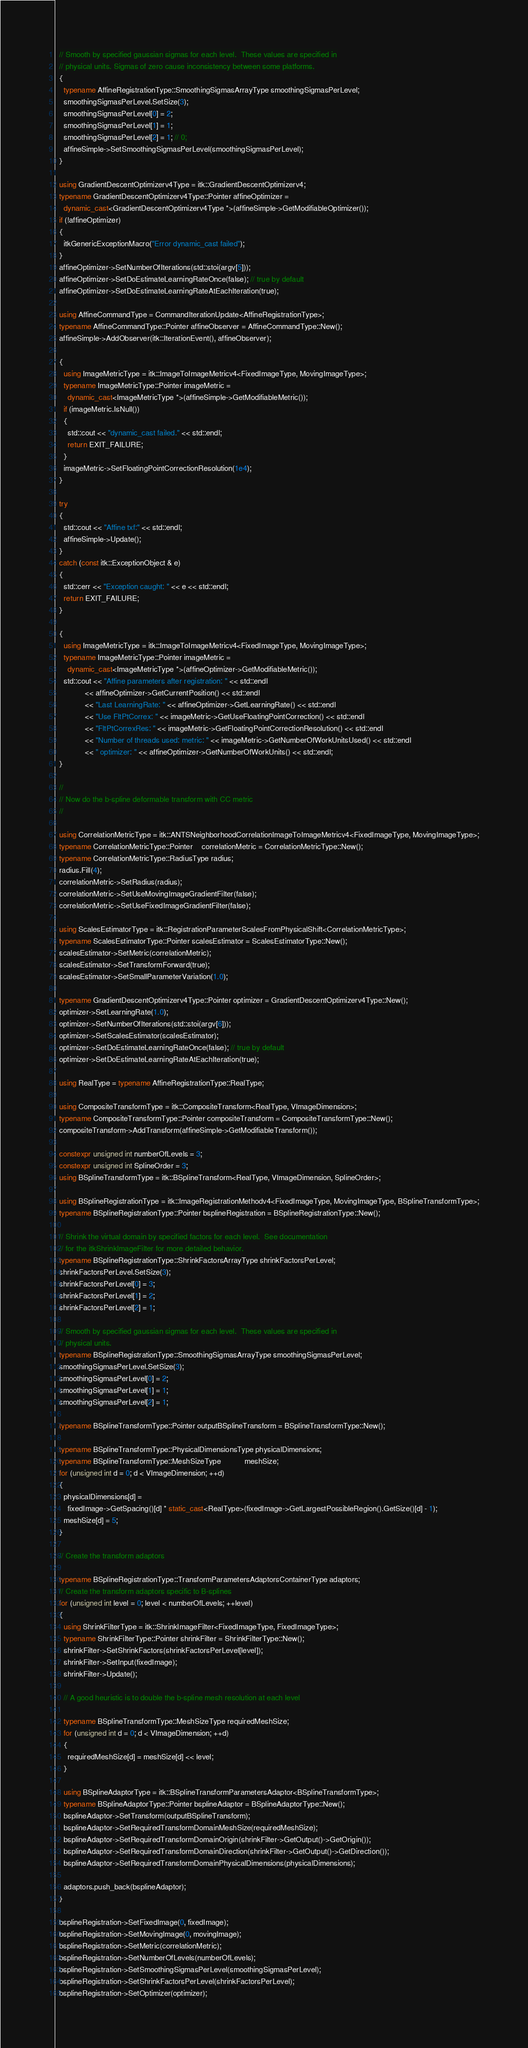<code> <loc_0><loc_0><loc_500><loc_500><_C++_>  // Smooth by specified gaussian sigmas for each level.  These values are specified in
  // physical units. Sigmas of zero cause inconsistency between some platforms.
  {
    typename AffineRegistrationType::SmoothingSigmasArrayType smoothingSigmasPerLevel;
    smoothingSigmasPerLevel.SetSize(3);
    smoothingSigmasPerLevel[0] = 2;
    smoothingSigmasPerLevel[1] = 1;
    smoothingSigmasPerLevel[2] = 1; // 0;
    affineSimple->SetSmoothingSigmasPerLevel(smoothingSigmasPerLevel);
  }

  using GradientDescentOptimizerv4Type = itk::GradientDescentOptimizerv4;
  typename GradientDescentOptimizerv4Type::Pointer affineOptimizer =
    dynamic_cast<GradientDescentOptimizerv4Type *>(affineSimple->GetModifiableOptimizer());
  if (!affineOptimizer)
  {
    itkGenericExceptionMacro("Error dynamic_cast failed");
  }
  affineOptimizer->SetNumberOfIterations(std::stoi(argv[5]));
  affineOptimizer->SetDoEstimateLearningRateOnce(false); // true by default
  affineOptimizer->SetDoEstimateLearningRateAtEachIteration(true);

  using AffineCommandType = CommandIterationUpdate<AffineRegistrationType>;
  typename AffineCommandType::Pointer affineObserver = AffineCommandType::New();
  affineSimple->AddObserver(itk::IterationEvent(), affineObserver);

  {
    using ImageMetricType = itk::ImageToImageMetricv4<FixedImageType, MovingImageType>;
    typename ImageMetricType::Pointer imageMetric =
      dynamic_cast<ImageMetricType *>(affineSimple->GetModifiableMetric());
    if (imageMetric.IsNull())
    {
      std::cout << "dynamic_cast failed." << std::endl;
      return EXIT_FAILURE;
    }
    imageMetric->SetFloatingPointCorrectionResolution(1e4);
  }

  try
  {
    std::cout << "Affine txf:" << std::endl;
    affineSimple->Update();
  }
  catch (const itk::ExceptionObject & e)
  {
    std::cerr << "Exception caught: " << e << std::endl;
    return EXIT_FAILURE;
  }

  {
    using ImageMetricType = itk::ImageToImageMetricv4<FixedImageType, MovingImageType>;
    typename ImageMetricType::Pointer imageMetric =
      dynamic_cast<ImageMetricType *>(affineOptimizer->GetModifiableMetric());
    std::cout << "Affine parameters after registration: " << std::endl
              << affineOptimizer->GetCurrentPosition() << std::endl
              << "Last LearningRate: " << affineOptimizer->GetLearningRate() << std::endl
              << "Use FltPtCorrex: " << imageMetric->GetUseFloatingPointCorrection() << std::endl
              << "FltPtCorrexRes: " << imageMetric->GetFloatingPointCorrectionResolution() << std::endl
              << "Number of threads used: metric: " << imageMetric->GetNumberOfWorkUnitsUsed() << std::endl
              << " optimizer: " << affineOptimizer->GetNumberOfWorkUnits() << std::endl;
  }

  //
  // Now do the b-spline deformable transform with CC metric
  //

  using CorrelationMetricType = itk::ANTSNeighborhoodCorrelationImageToImageMetricv4<FixedImageType, MovingImageType>;
  typename CorrelationMetricType::Pointer    correlationMetric = CorrelationMetricType::New();
  typename CorrelationMetricType::RadiusType radius;
  radius.Fill(4);
  correlationMetric->SetRadius(radius);
  correlationMetric->SetUseMovingImageGradientFilter(false);
  correlationMetric->SetUseFixedImageGradientFilter(false);

  using ScalesEstimatorType = itk::RegistrationParameterScalesFromPhysicalShift<CorrelationMetricType>;
  typename ScalesEstimatorType::Pointer scalesEstimator = ScalesEstimatorType::New();
  scalesEstimator->SetMetric(correlationMetric);
  scalesEstimator->SetTransformForward(true);
  scalesEstimator->SetSmallParameterVariation(1.0);

  typename GradientDescentOptimizerv4Type::Pointer optimizer = GradientDescentOptimizerv4Type::New();
  optimizer->SetLearningRate(1.0);
  optimizer->SetNumberOfIterations(std::stoi(argv[6]));
  optimizer->SetScalesEstimator(scalesEstimator);
  optimizer->SetDoEstimateLearningRateOnce(false); // true by default
  optimizer->SetDoEstimateLearningRateAtEachIteration(true);

  using RealType = typename AffineRegistrationType::RealType;

  using CompositeTransformType = itk::CompositeTransform<RealType, VImageDimension>;
  typename CompositeTransformType::Pointer compositeTransform = CompositeTransformType::New();
  compositeTransform->AddTransform(affineSimple->GetModifiableTransform());

  constexpr unsigned int numberOfLevels = 3;
  constexpr unsigned int SplineOrder = 3;
  using BSplineTransformType = itk::BSplineTransform<RealType, VImageDimension, SplineOrder>;

  using BSplineRegistrationType = itk::ImageRegistrationMethodv4<FixedImageType, MovingImageType, BSplineTransformType>;
  typename BSplineRegistrationType::Pointer bsplineRegistration = BSplineRegistrationType::New();

  // Shrink the virtual domain by specified factors for each level.  See documentation
  // for the itkShrinkImageFilter for more detailed behavior.
  typename BSplineRegistrationType::ShrinkFactorsArrayType shrinkFactorsPerLevel;
  shrinkFactorsPerLevel.SetSize(3);
  shrinkFactorsPerLevel[0] = 3;
  shrinkFactorsPerLevel[1] = 2;
  shrinkFactorsPerLevel[2] = 1;

  // Smooth by specified gaussian sigmas for each level.  These values are specified in
  // physical units.
  typename BSplineRegistrationType::SmoothingSigmasArrayType smoothingSigmasPerLevel;
  smoothingSigmasPerLevel.SetSize(3);
  smoothingSigmasPerLevel[0] = 2;
  smoothingSigmasPerLevel[1] = 1;
  smoothingSigmasPerLevel[2] = 1;

  typename BSplineTransformType::Pointer outputBSplineTransform = BSplineTransformType::New();

  typename BSplineTransformType::PhysicalDimensionsType physicalDimensions;
  typename BSplineTransformType::MeshSizeType           meshSize;
  for (unsigned int d = 0; d < VImageDimension; ++d)
  {
    physicalDimensions[d] =
      fixedImage->GetSpacing()[d] * static_cast<RealType>(fixedImage->GetLargestPossibleRegion().GetSize()[d] - 1);
    meshSize[d] = 5;
  }

  // Create the transform adaptors

  typename BSplineRegistrationType::TransformParametersAdaptorsContainerType adaptors;
  // Create the transform adaptors specific to B-splines
  for (unsigned int level = 0; level < numberOfLevels; ++level)
  {
    using ShrinkFilterType = itk::ShrinkImageFilter<FixedImageType, FixedImageType>;
    typename ShrinkFilterType::Pointer shrinkFilter = ShrinkFilterType::New();
    shrinkFilter->SetShrinkFactors(shrinkFactorsPerLevel[level]);
    shrinkFilter->SetInput(fixedImage);
    shrinkFilter->Update();

    // A good heuristic is to double the b-spline mesh resolution at each level

    typename BSplineTransformType::MeshSizeType requiredMeshSize;
    for (unsigned int d = 0; d < VImageDimension; ++d)
    {
      requiredMeshSize[d] = meshSize[d] << level;
    }

    using BSplineAdaptorType = itk::BSplineTransformParametersAdaptor<BSplineTransformType>;
    typename BSplineAdaptorType::Pointer bsplineAdaptor = BSplineAdaptorType::New();
    bsplineAdaptor->SetTransform(outputBSplineTransform);
    bsplineAdaptor->SetRequiredTransformDomainMeshSize(requiredMeshSize);
    bsplineAdaptor->SetRequiredTransformDomainOrigin(shrinkFilter->GetOutput()->GetOrigin());
    bsplineAdaptor->SetRequiredTransformDomainDirection(shrinkFilter->GetOutput()->GetDirection());
    bsplineAdaptor->SetRequiredTransformDomainPhysicalDimensions(physicalDimensions);

    adaptors.push_back(bsplineAdaptor);
  }

  bsplineRegistration->SetFixedImage(0, fixedImage);
  bsplineRegistration->SetMovingImage(0, movingImage);
  bsplineRegistration->SetMetric(correlationMetric);
  bsplineRegistration->SetNumberOfLevels(numberOfLevels);
  bsplineRegistration->SetSmoothingSigmasPerLevel(smoothingSigmasPerLevel);
  bsplineRegistration->SetShrinkFactorsPerLevel(shrinkFactorsPerLevel);
  bsplineRegistration->SetOptimizer(optimizer);</code> 